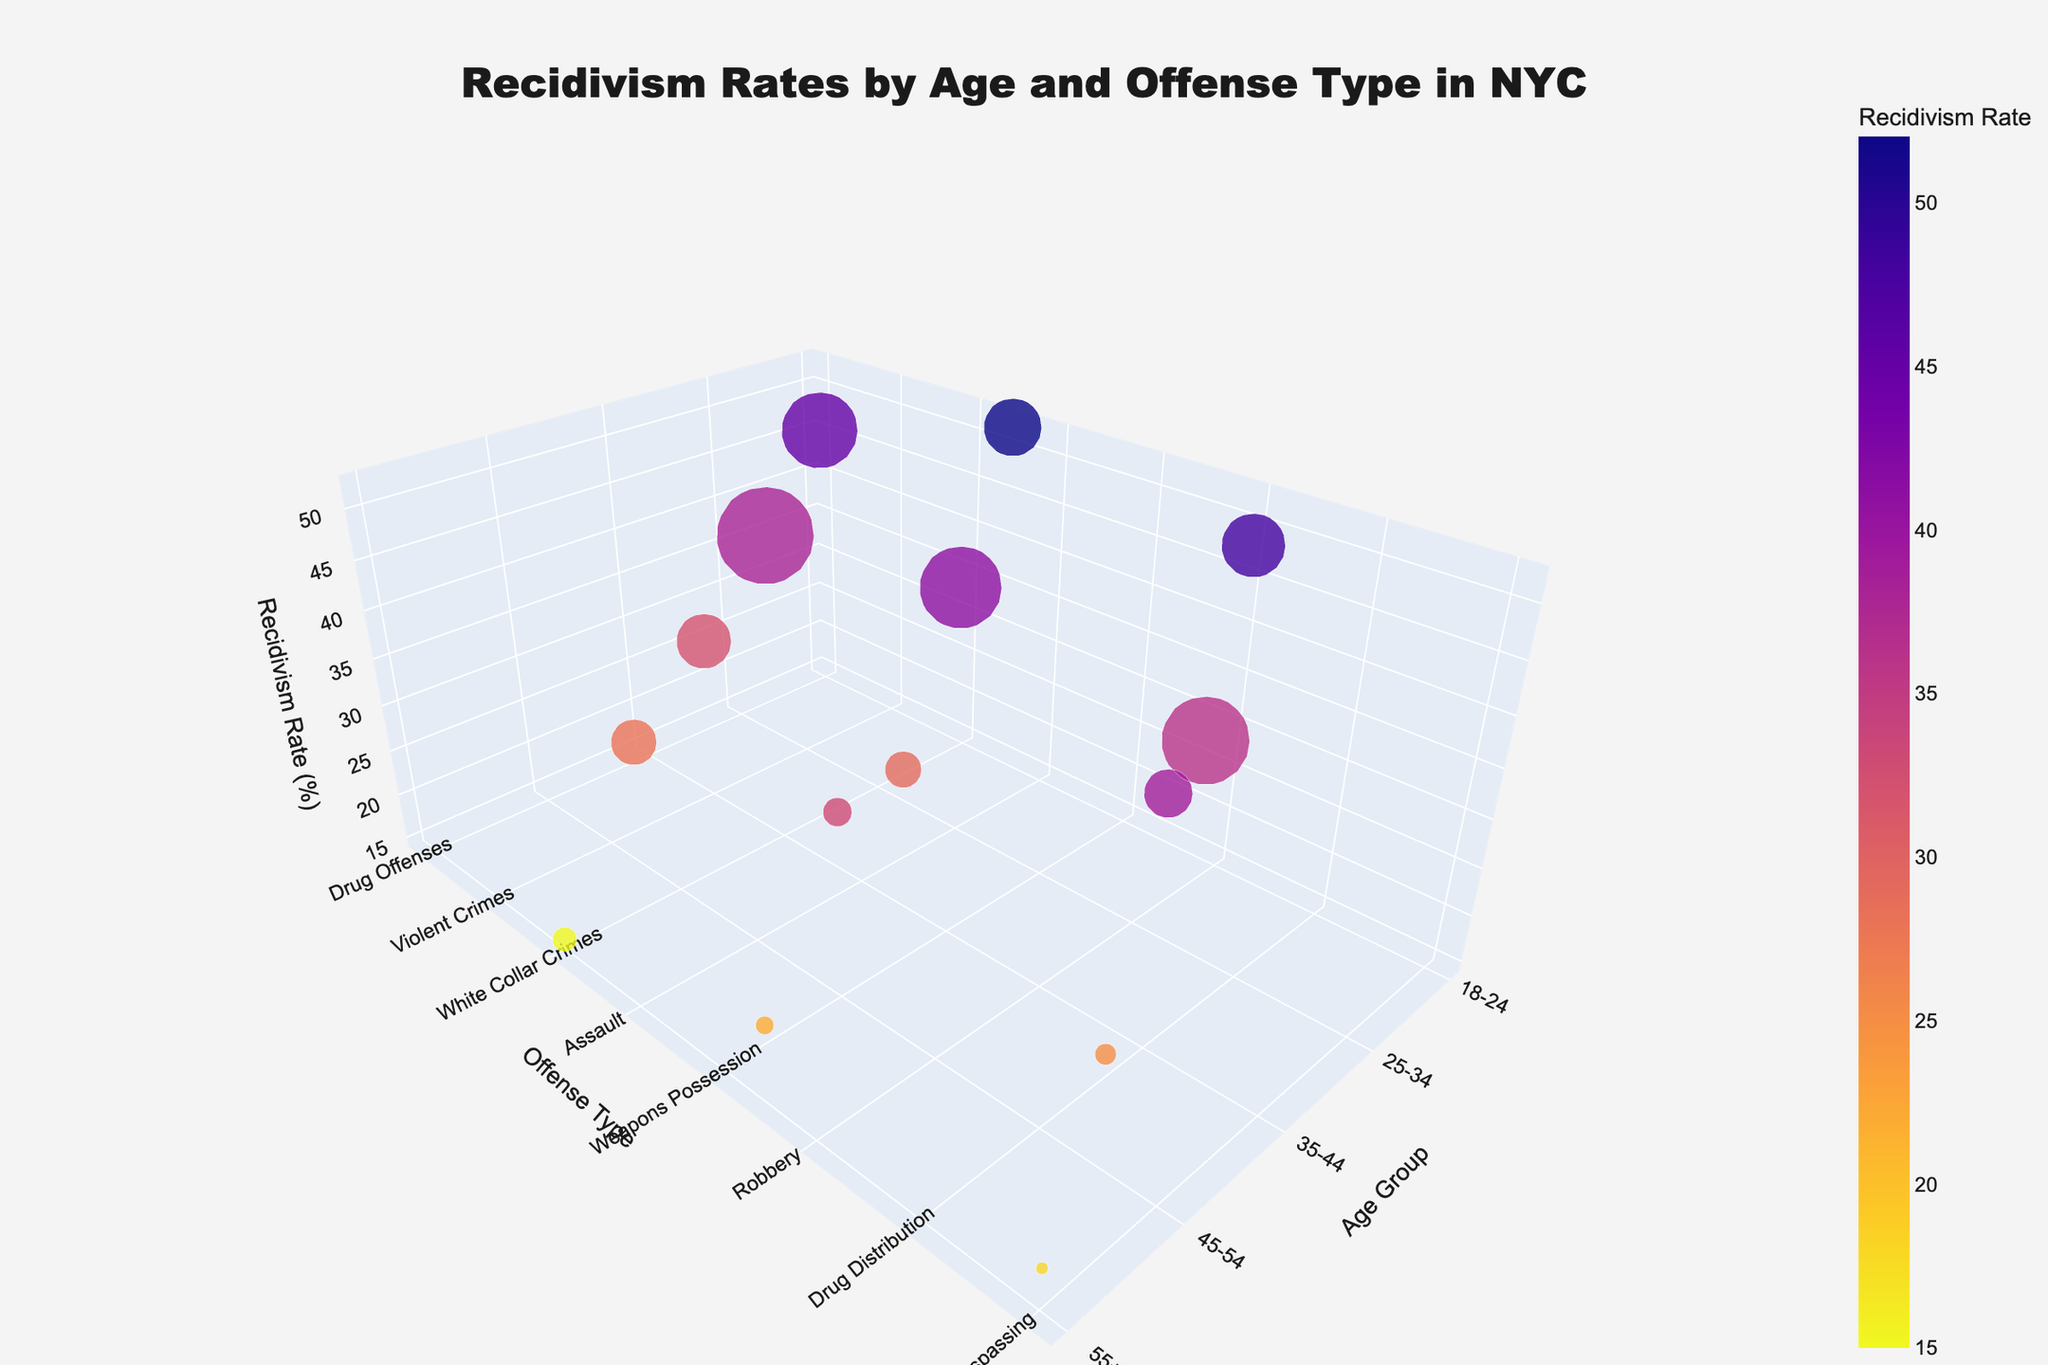What is the title of the 3D bubble chart? The title of the chart is displayed at the top center of the figure.
Answer: "Recidivism Rates by Age and Offense Type in NYC" Which age group has the highest recidivism rate for any offense type? You need to look for the highest point along the z-axis labelled "Recidivism Rate (%)" and refer to the corresponding age group on the x-axis.
Answer: 18-24 Which offense type has the lowest number of cases for the age group 55+? Search for the data points corresponding to the age group 55+ along the x-axis and check the size of the bubbles to identify the smallest one.
Answer: Trespassing What is the recidivism rate for Drug Offenses among the age group 18-24? Find the data point where the x-axis labels are "18-24" and y-axis labels are "Drug Offenses". The height of this point on the z-axis indicates the recidivism rate.
Answer: 45% Compare the recidivism rates between Drug Offenses for the 18-24 age group and Drug Distribution for the 35-44 age group. Which one is higher? Locate the two data points: one for Drug Offenses among 18-24 and the other for Drug Distribution among 35-44. Compare their heights along the z-axis.
Answer: Drug Offenses for 18-24 Which offense type has the highest recidivism rate across all age groups? Identify the highest bubble along the z-axis, and check the corresponding offense type on the y-axis.
Answer: Burglary How many offense types have a recidivism rate of 25% or lower for the age group 45-54? Examine the data points for the age group 45-54 on the x-axis and count how many points are at or below the 25% mark on the z-axis.
Answer: 1 What is the difference in recidivism rates between Burglary and Robbery for the 18-24 age group? Locate the Burglary and Robbery data points for the 18-24 age group on both the x and y axes. Subtract the recidivism rate of Robbery from Burglary.
Answer: 52% - 48% = 4% What is the average recidivism rate for all offense types for the age group 55+? Identify all points corresponding to age group 55+ on the x-axis, sum their recidivism rates, and divide by the number of points.
Answer: (15 + 22 + 18) / 3 = 55 / 3 = ~18.33% Which age group-offense type combination has the maximum number of cases? Search for the largest bubble size across the entire chart and identify the corresponding age group and offense type.
Answer: Property Crimes for 25-34 